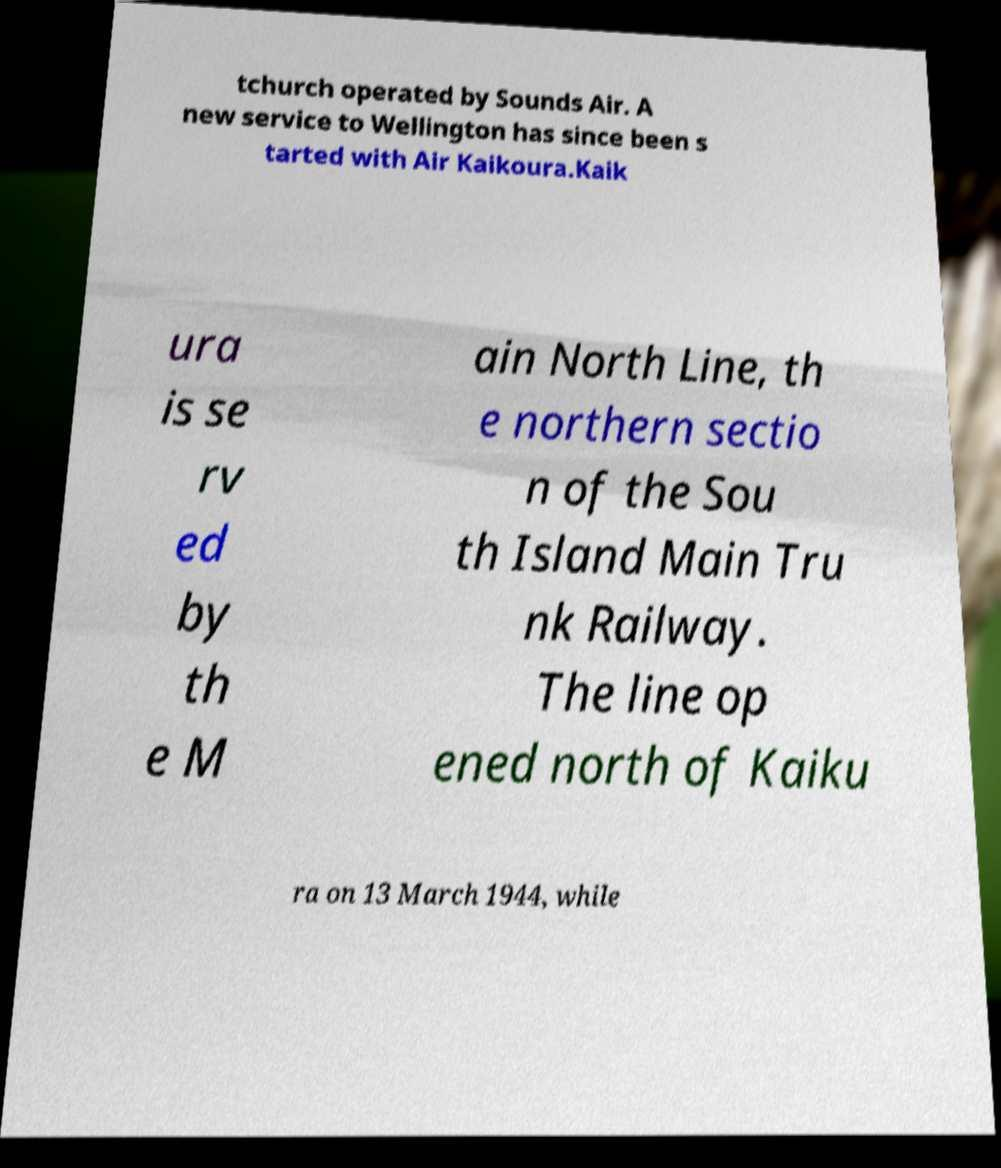Can you accurately transcribe the text from the provided image for me? tchurch operated by Sounds Air. A new service to Wellington has since been s tarted with Air Kaikoura.Kaik ura is se rv ed by th e M ain North Line, th e northern sectio n of the Sou th Island Main Tru nk Railway. The line op ened north of Kaiku ra on 13 March 1944, while 